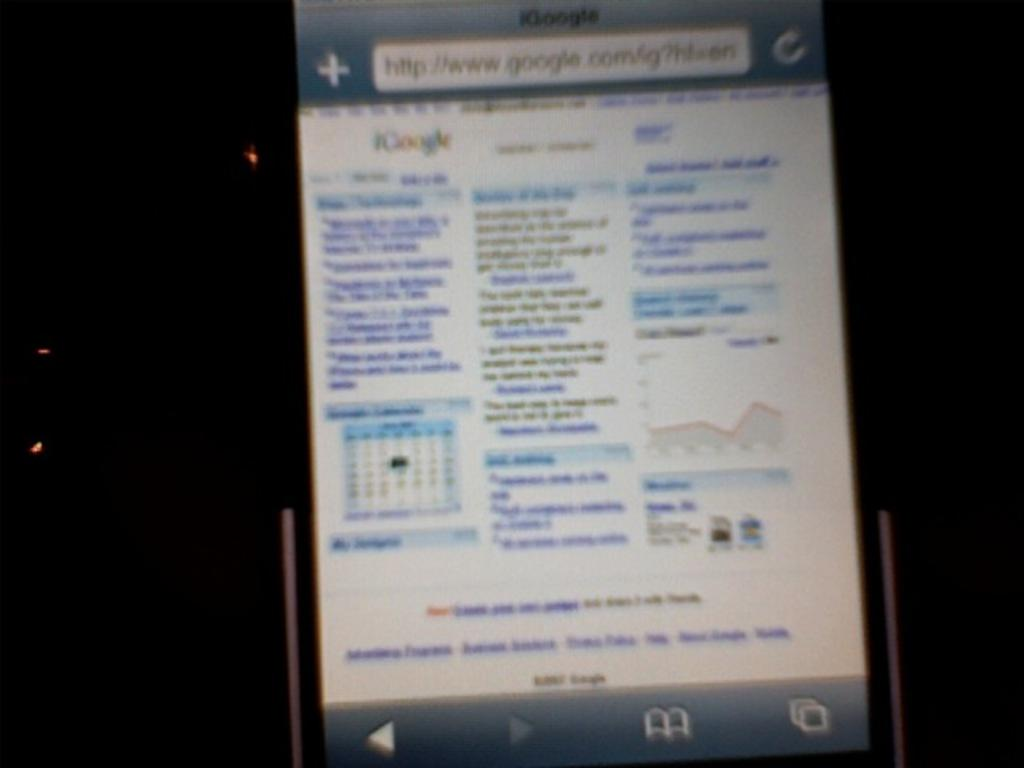Provide a one-sentence caption for the provided image. a cell phone on which someone is searching for something from google. 